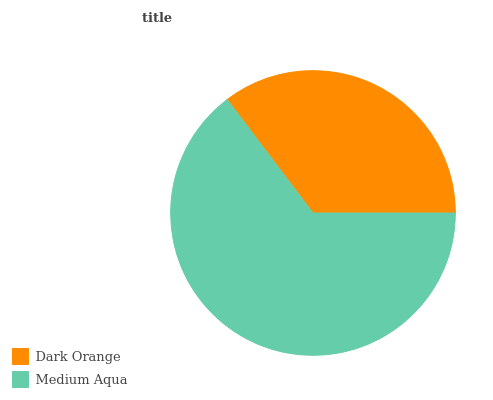Is Dark Orange the minimum?
Answer yes or no. Yes. Is Medium Aqua the maximum?
Answer yes or no. Yes. Is Medium Aqua the minimum?
Answer yes or no. No. Is Medium Aqua greater than Dark Orange?
Answer yes or no. Yes. Is Dark Orange less than Medium Aqua?
Answer yes or no. Yes. Is Dark Orange greater than Medium Aqua?
Answer yes or no. No. Is Medium Aqua less than Dark Orange?
Answer yes or no. No. Is Medium Aqua the high median?
Answer yes or no. Yes. Is Dark Orange the low median?
Answer yes or no. Yes. Is Dark Orange the high median?
Answer yes or no. No. Is Medium Aqua the low median?
Answer yes or no. No. 